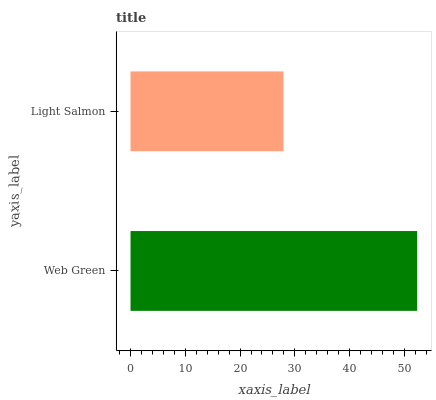Is Light Salmon the minimum?
Answer yes or no. Yes. Is Web Green the maximum?
Answer yes or no. Yes. Is Light Salmon the maximum?
Answer yes or no. No. Is Web Green greater than Light Salmon?
Answer yes or no. Yes. Is Light Salmon less than Web Green?
Answer yes or no. Yes. Is Light Salmon greater than Web Green?
Answer yes or no. No. Is Web Green less than Light Salmon?
Answer yes or no. No. Is Web Green the high median?
Answer yes or no. Yes. Is Light Salmon the low median?
Answer yes or no. Yes. Is Light Salmon the high median?
Answer yes or no. No. Is Web Green the low median?
Answer yes or no. No. 